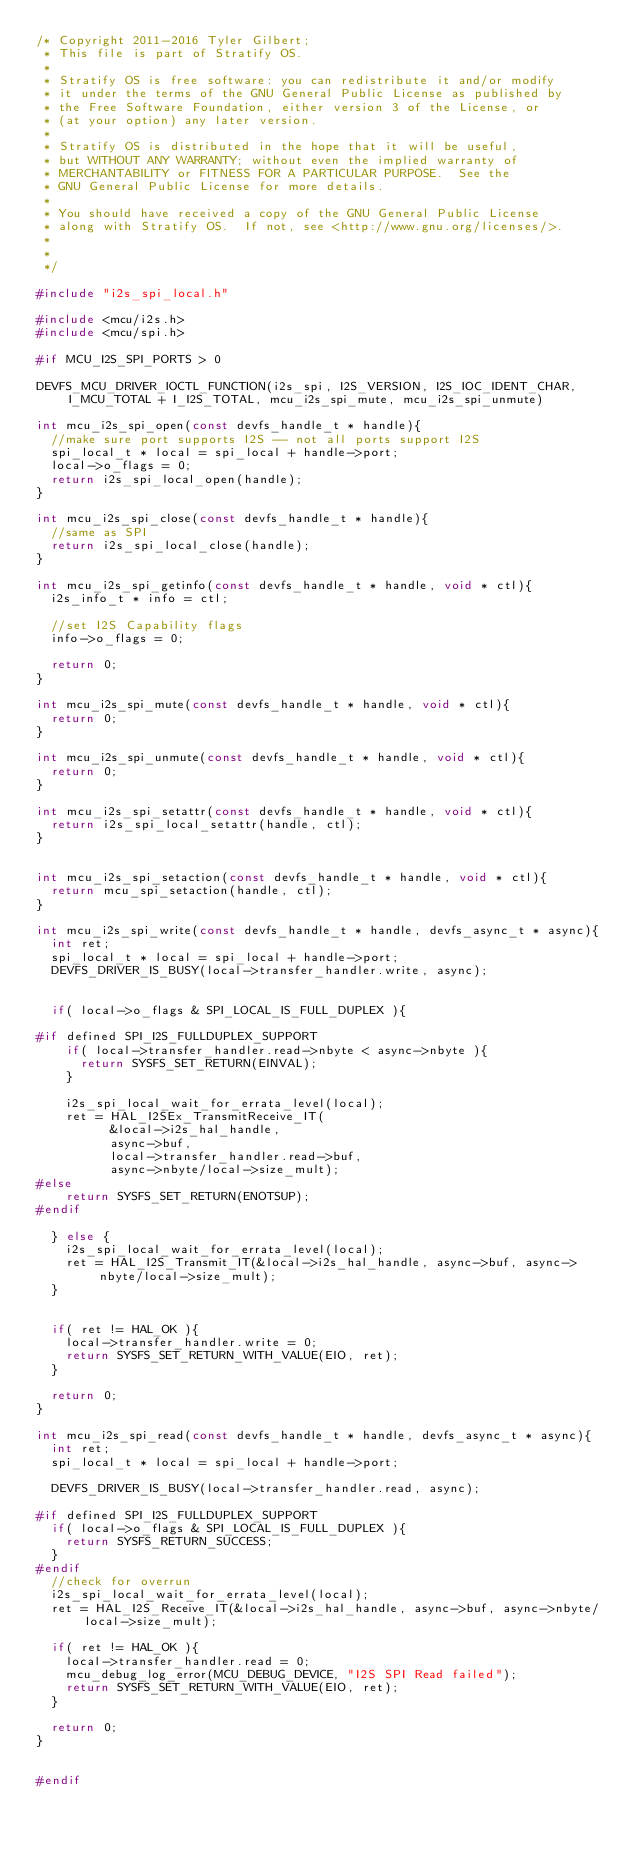Convert code to text. <code><loc_0><loc_0><loc_500><loc_500><_C_>/* Copyright 2011-2016 Tyler Gilbert; 
 * This file is part of Stratify OS.
 *
 * Stratify OS is free software: you can redistribute it and/or modify
 * it under the terms of the GNU General Public License as published by
 * the Free Software Foundation, either version 3 of the License, or
 * (at your option) any later version.
 *
 * Stratify OS is distributed in the hope that it will be useful,
 * but WITHOUT ANY WARRANTY; without even the implied warranty of
 * MERCHANTABILITY or FITNESS FOR A PARTICULAR PURPOSE.  See the
 * GNU General Public License for more details.
 *
 * You should have received a copy of the GNU General Public License
 * along with Stratify OS.  If not, see <http://www.gnu.org/licenses/>.
 *
 *
 */

#include "i2s_spi_local.h"

#include <mcu/i2s.h>
#include <mcu/spi.h>

#if MCU_I2S_SPI_PORTS > 0

DEVFS_MCU_DRIVER_IOCTL_FUNCTION(i2s_spi, I2S_VERSION, I2S_IOC_IDENT_CHAR, I_MCU_TOTAL + I_I2S_TOTAL, mcu_i2s_spi_mute, mcu_i2s_spi_unmute)

int mcu_i2s_spi_open(const devfs_handle_t * handle){
	//make sure port supports I2S -- not all ports support I2S
	spi_local_t * local = spi_local + handle->port;
	local->o_flags = 0;
	return i2s_spi_local_open(handle);
}

int mcu_i2s_spi_close(const devfs_handle_t * handle){
	//same as SPI
	return i2s_spi_local_close(handle);
}

int mcu_i2s_spi_getinfo(const devfs_handle_t * handle, void * ctl){
	i2s_info_t * info = ctl;

	//set I2S Capability flags
	info->o_flags = 0;

	return 0;
}

int mcu_i2s_spi_mute(const devfs_handle_t * handle, void * ctl){
	return 0;
}

int mcu_i2s_spi_unmute(const devfs_handle_t * handle, void * ctl){
	return 0;
}

int mcu_i2s_spi_setattr(const devfs_handle_t * handle, void * ctl){
	return i2s_spi_local_setattr(handle, ctl);
}


int mcu_i2s_spi_setaction(const devfs_handle_t * handle, void * ctl){
	return mcu_spi_setaction(handle, ctl);
}

int mcu_i2s_spi_write(const devfs_handle_t * handle, devfs_async_t * async){
	int ret;
	spi_local_t * local = spi_local + handle->port;
	DEVFS_DRIVER_IS_BUSY(local->transfer_handler.write, async);


	if( local->o_flags & SPI_LOCAL_IS_FULL_DUPLEX ){

#if defined SPI_I2S_FULLDUPLEX_SUPPORT
		if( local->transfer_handler.read->nbyte < async->nbyte ){
			return SYSFS_SET_RETURN(EINVAL);
		}

		i2s_spi_local_wait_for_errata_level(local);
		ret = HAL_I2SEx_TransmitReceive_IT(
					&local->i2s_hal_handle,
					async->buf,
					local->transfer_handler.read->buf,
					async->nbyte/local->size_mult);
#else
		return SYSFS_SET_RETURN(ENOTSUP);
#endif

	} else {
		i2s_spi_local_wait_for_errata_level(local);
		ret = HAL_I2S_Transmit_IT(&local->i2s_hal_handle, async->buf, async->nbyte/local->size_mult);
	}


	if( ret != HAL_OK ){
		local->transfer_handler.write = 0;
		return SYSFS_SET_RETURN_WITH_VALUE(EIO, ret);
	}

	return 0;
}

int mcu_i2s_spi_read(const devfs_handle_t * handle, devfs_async_t * async){
	int ret;
	spi_local_t * local = spi_local + handle->port;

	DEVFS_DRIVER_IS_BUSY(local->transfer_handler.read, async);

#if defined SPI_I2S_FULLDUPLEX_SUPPORT
	if( local->o_flags & SPI_LOCAL_IS_FULL_DUPLEX ){
		return SYSFS_RETURN_SUCCESS;
	}
#endif
	//check for overrun
	i2s_spi_local_wait_for_errata_level(local);
	ret = HAL_I2S_Receive_IT(&local->i2s_hal_handle, async->buf, async->nbyte/local->size_mult);

	if( ret != HAL_OK ){
		local->transfer_handler.read = 0;
		mcu_debug_log_error(MCU_DEBUG_DEVICE, "I2S SPI Read failed");
		return SYSFS_SET_RETURN_WITH_VALUE(EIO, ret);
	}

	return 0;
}


#endif

</code> 